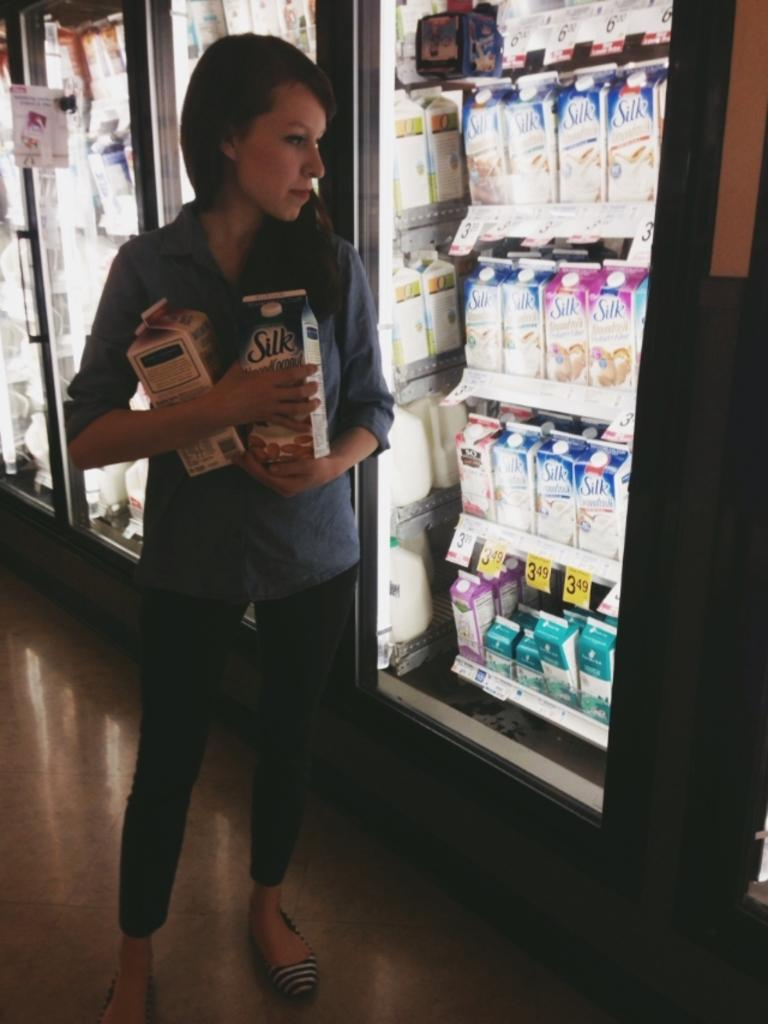<image>
Offer a succinct explanation of the picture presented. a woman stands in front of a dairy cooler full of silk almond milk 